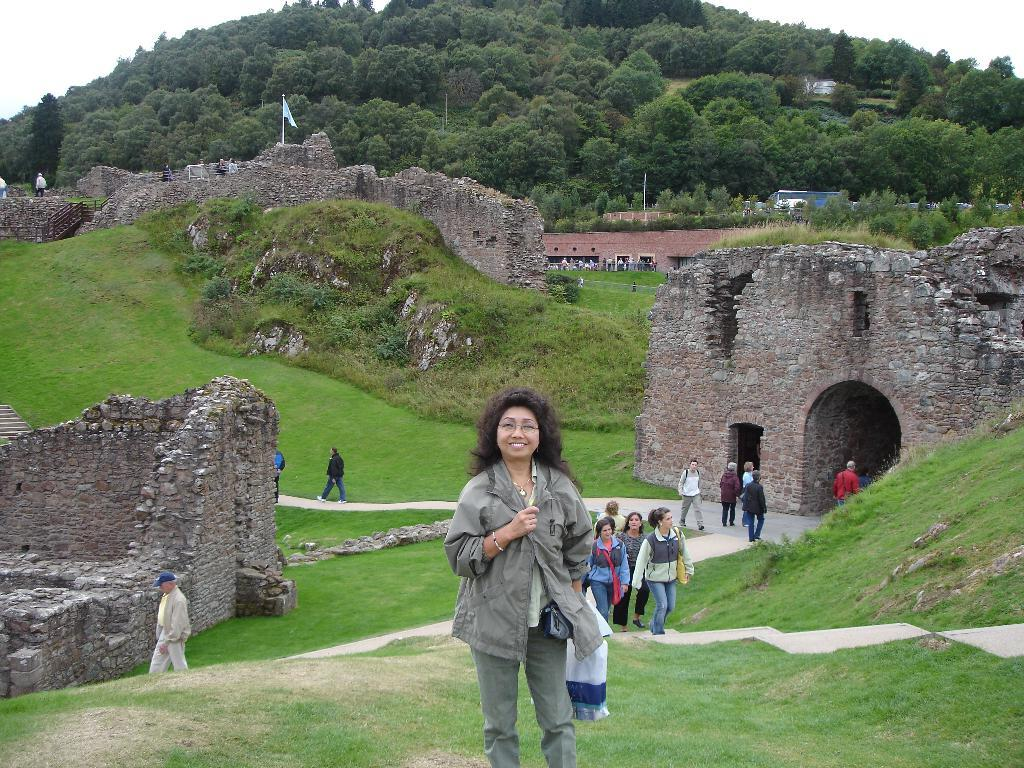How many people are in the image? There are people in the image, but the exact number is not specified. What type of natural environment is visible in the image? There is grass, trees, and the sky visible in the image. What man-made structures can be seen in the image? There are walls, railing, and a tunnel in the image. What is the flag associated with in the image? The flag is present in the image, but its specific purpose or location is not mentioned. What type of brass instrument is being played by the people in the image? There is no brass instrument or any indication of musical activity in the image. 